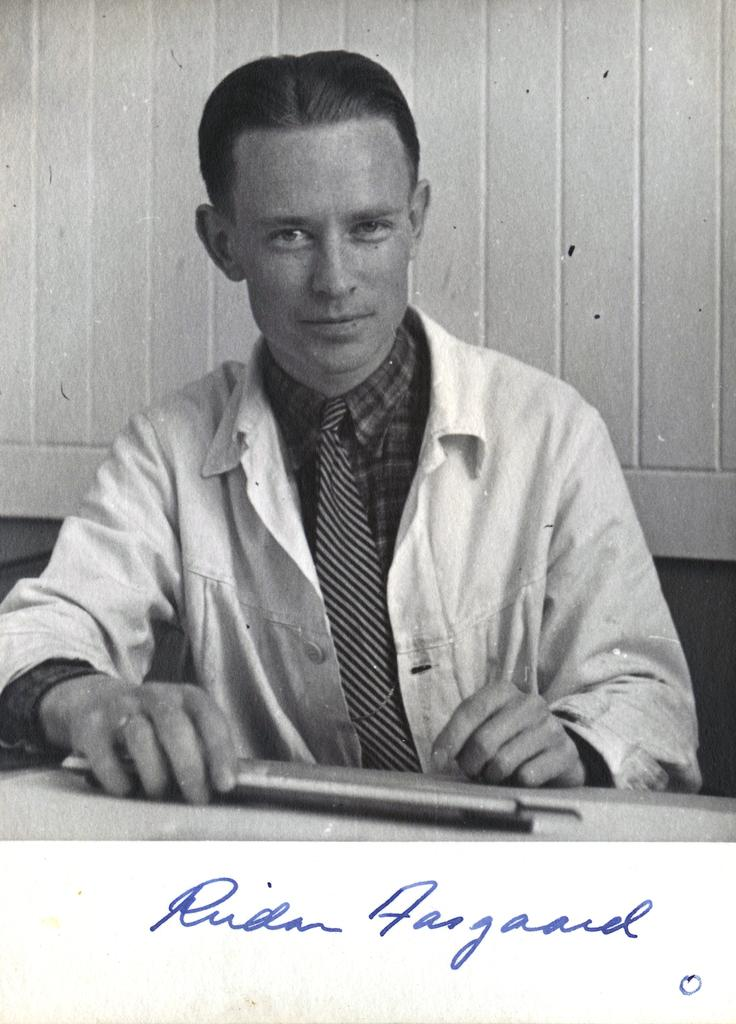Who is present in the image? There is a man in the image. What is the man wearing? The man is wearing a white apron. What is in front of the man? There is a table in front of the man. What is the color scheme of the image? The image is black and white. What can be seen at the bottom of the image? There is text visible at the bottom of the image. What type of gold object is visible on the table in the image? There is no gold object present in the image. Can you see a goat in the image? There is no goat present in the image. 